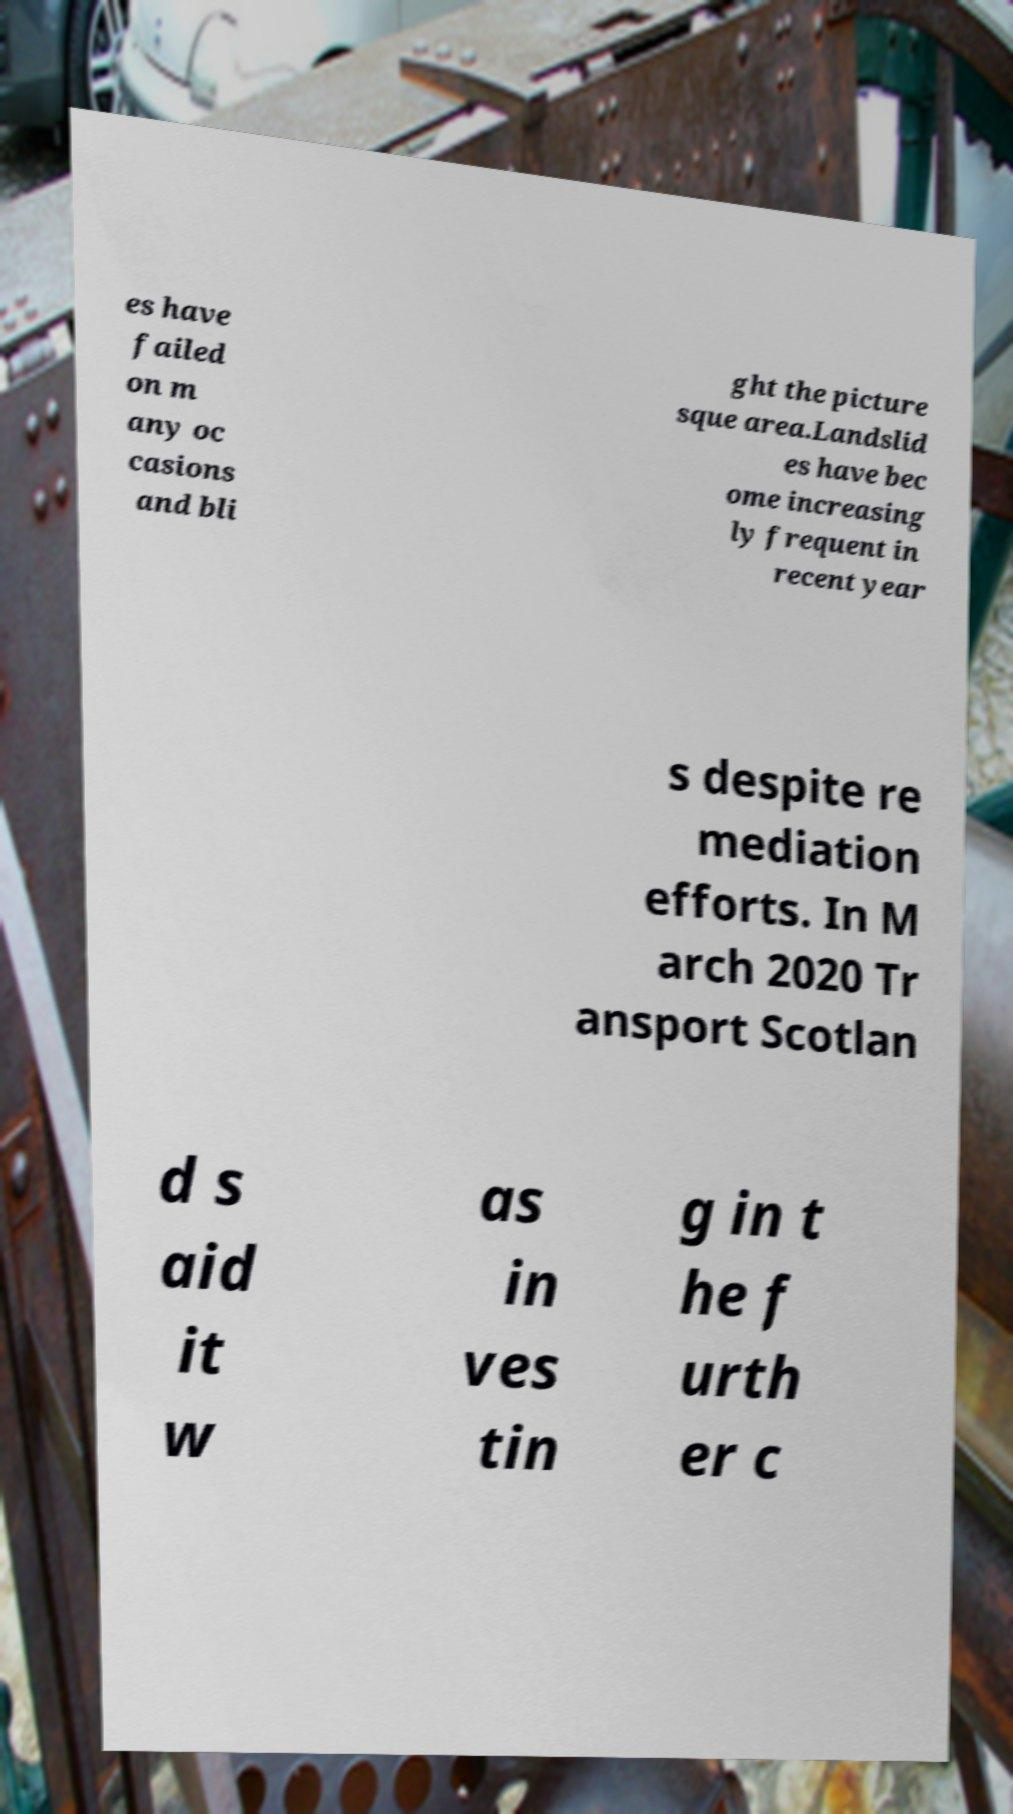For documentation purposes, I need the text within this image transcribed. Could you provide that? es have failed on m any oc casions and bli ght the picture sque area.Landslid es have bec ome increasing ly frequent in recent year s despite re mediation efforts. In M arch 2020 Tr ansport Scotlan d s aid it w as in ves tin g in t he f urth er c 